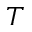Convert formula to latex. <formula><loc_0><loc_0><loc_500><loc_500>T</formula> 